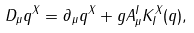Convert formula to latex. <formula><loc_0><loc_0><loc_500><loc_500>D _ { \mu } q ^ { X } = \partial _ { \mu } q ^ { X } + g A ^ { I } _ { \mu } K _ { I } ^ { X } ( q ) ,</formula> 